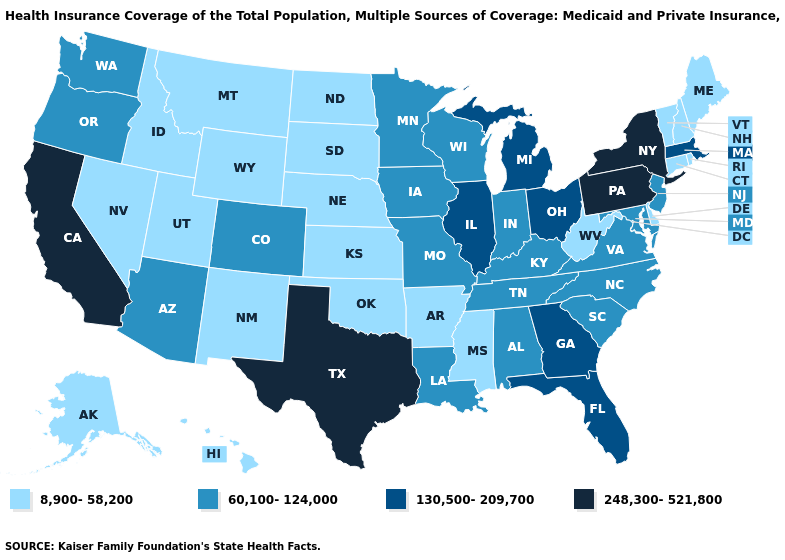What is the value of Michigan?
Give a very brief answer. 130,500-209,700. What is the lowest value in states that border Massachusetts?
Answer briefly. 8,900-58,200. What is the value of New Hampshire?
Write a very short answer. 8,900-58,200. Name the states that have a value in the range 130,500-209,700?
Be succinct. Florida, Georgia, Illinois, Massachusetts, Michigan, Ohio. Does the first symbol in the legend represent the smallest category?
Short answer required. Yes. Does Indiana have the lowest value in the MidWest?
Write a very short answer. No. Which states hav the highest value in the South?
Concise answer only. Texas. What is the highest value in the USA?
Be succinct. 248,300-521,800. What is the value of Vermont?
Concise answer only. 8,900-58,200. What is the value of Pennsylvania?
Write a very short answer. 248,300-521,800. Is the legend a continuous bar?
Answer briefly. No. Among the states that border Arizona , does Nevada have the highest value?
Quick response, please. No. What is the highest value in the USA?
Concise answer only. 248,300-521,800. What is the value of West Virginia?
Quick response, please. 8,900-58,200. Name the states that have a value in the range 130,500-209,700?
Be succinct. Florida, Georgia, Illinois, Massachusetts, Michigan, Ohio. 